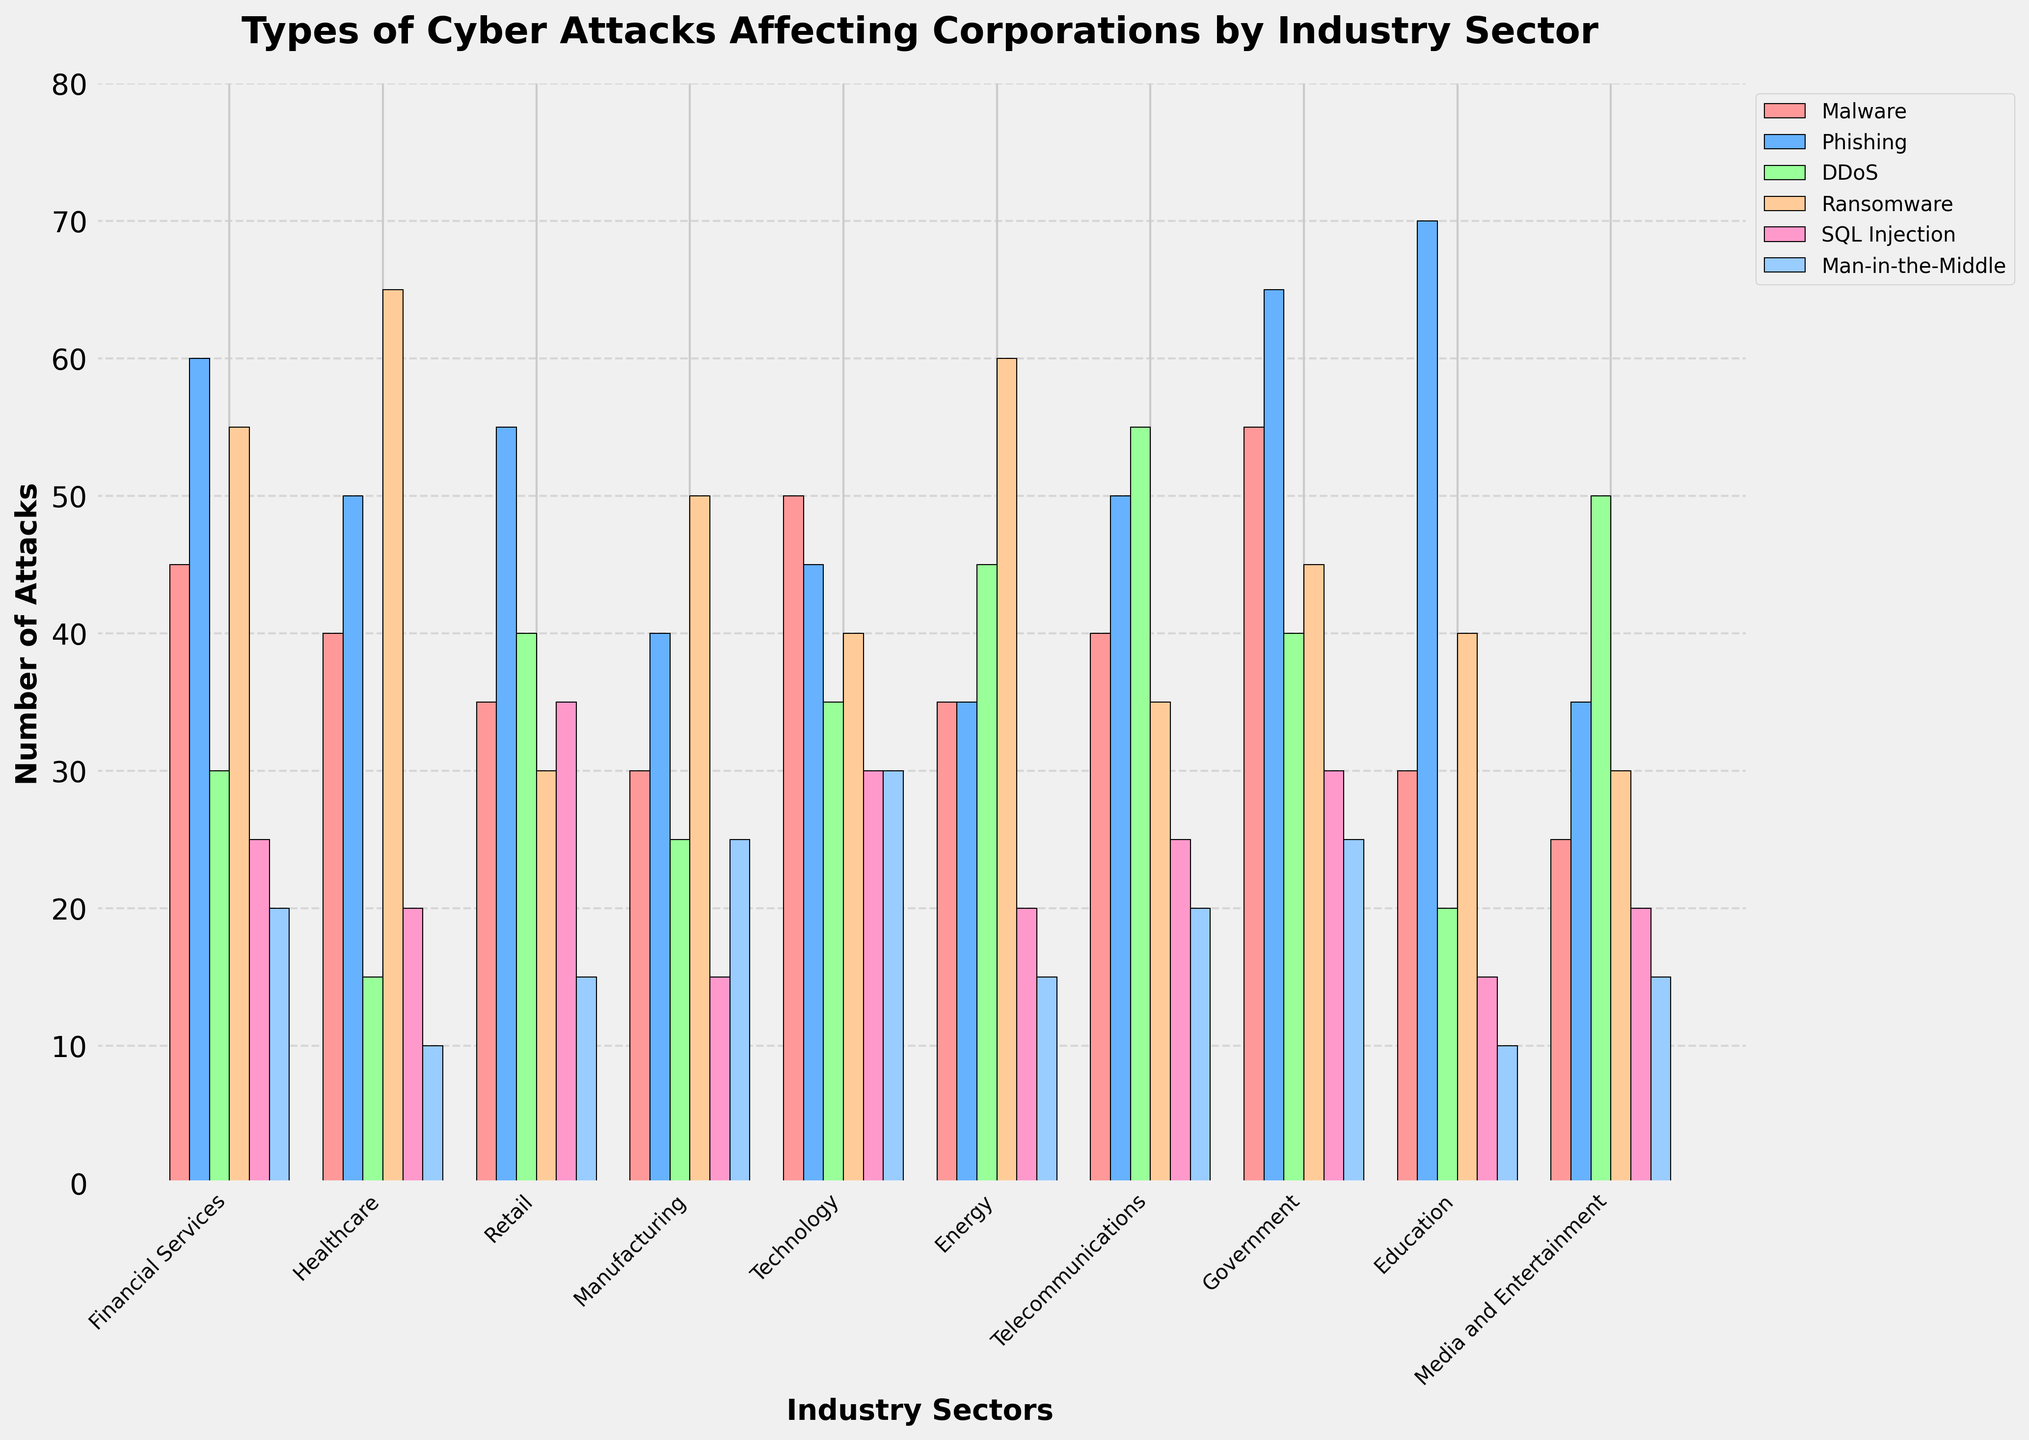Which industry sector experiences the highest number of phishing attacks? Look at the bar corresponding to phishing attacks for each industry. The government sector has the highest bar for phishing attacks.
Answer: Government Which two industry sectors have the same number of SQL injection attacks? Compare the heights of the bars for SQL injection attacks across all industries. Financial Services and Telecommunications both have 25 SQL injection attacks.
Answer: Financial Services, Telecommunications What is the total number of ransomware attacks in Financial Services and Healthcare industries combined? Sum the number of ransomware attacks in Financial Services (55) and Healthcare (65). 55 + 65 = 120.
Answer: 120 Which industry sector has the lowest number of malware attacks? Look at the height of the bars for malware attacks for all industries. The Media and Entertainment sector has the lowest bar for malware attacks.
Answer: Media and Entertainment Does the education sector experience more DDoS attacks or ransomware attacks? Compare the height of the bars for DDoS (20) and ransomware (40) in the education sector. The bar for ransomware is higher.
Answer: Ransomware What is the difference in the number of man-in-the-middle attacks between the Manufacturing and Media & Entertainment sectors? Subtract the number of man-in-the-middle attacks in Media & Entertainment (15) from Manufacturing (25). 25 - 15 = 10.
Answer: 10 How many more phishing attacks does the financial services sector experience compared to the energy sector? Subtract the number of phishing attacks in the energy sector (35) from the financial services sector (60). 60 - 35 = 25.
Answer: 25 Which industry experiences more types of attacks with bar heights higher than 50? Count the number of bars higher than 50 for each industry. Both Government and Education sectors have multiple bars higher than 50.
Answer: Government, Education What is the average number of attacks for DDoS in the Government, Media and Entertainment, and Telecommunications sectors? Average the number of DDoS attacks in Government (40), Media and Entertainment (50), and Telecommunications (55). (40 + 50 + 55) / 3 = 145 / 3 ≈ 48.33.
Answer: 48.33 Which industry sector experiences equal numbers of malware and ransomware attacks? Compare the heights of the bars for malware and ransomware in each industry. The Energy sector has 35 for both malware and ransomware attacks.
Answer: Energy 